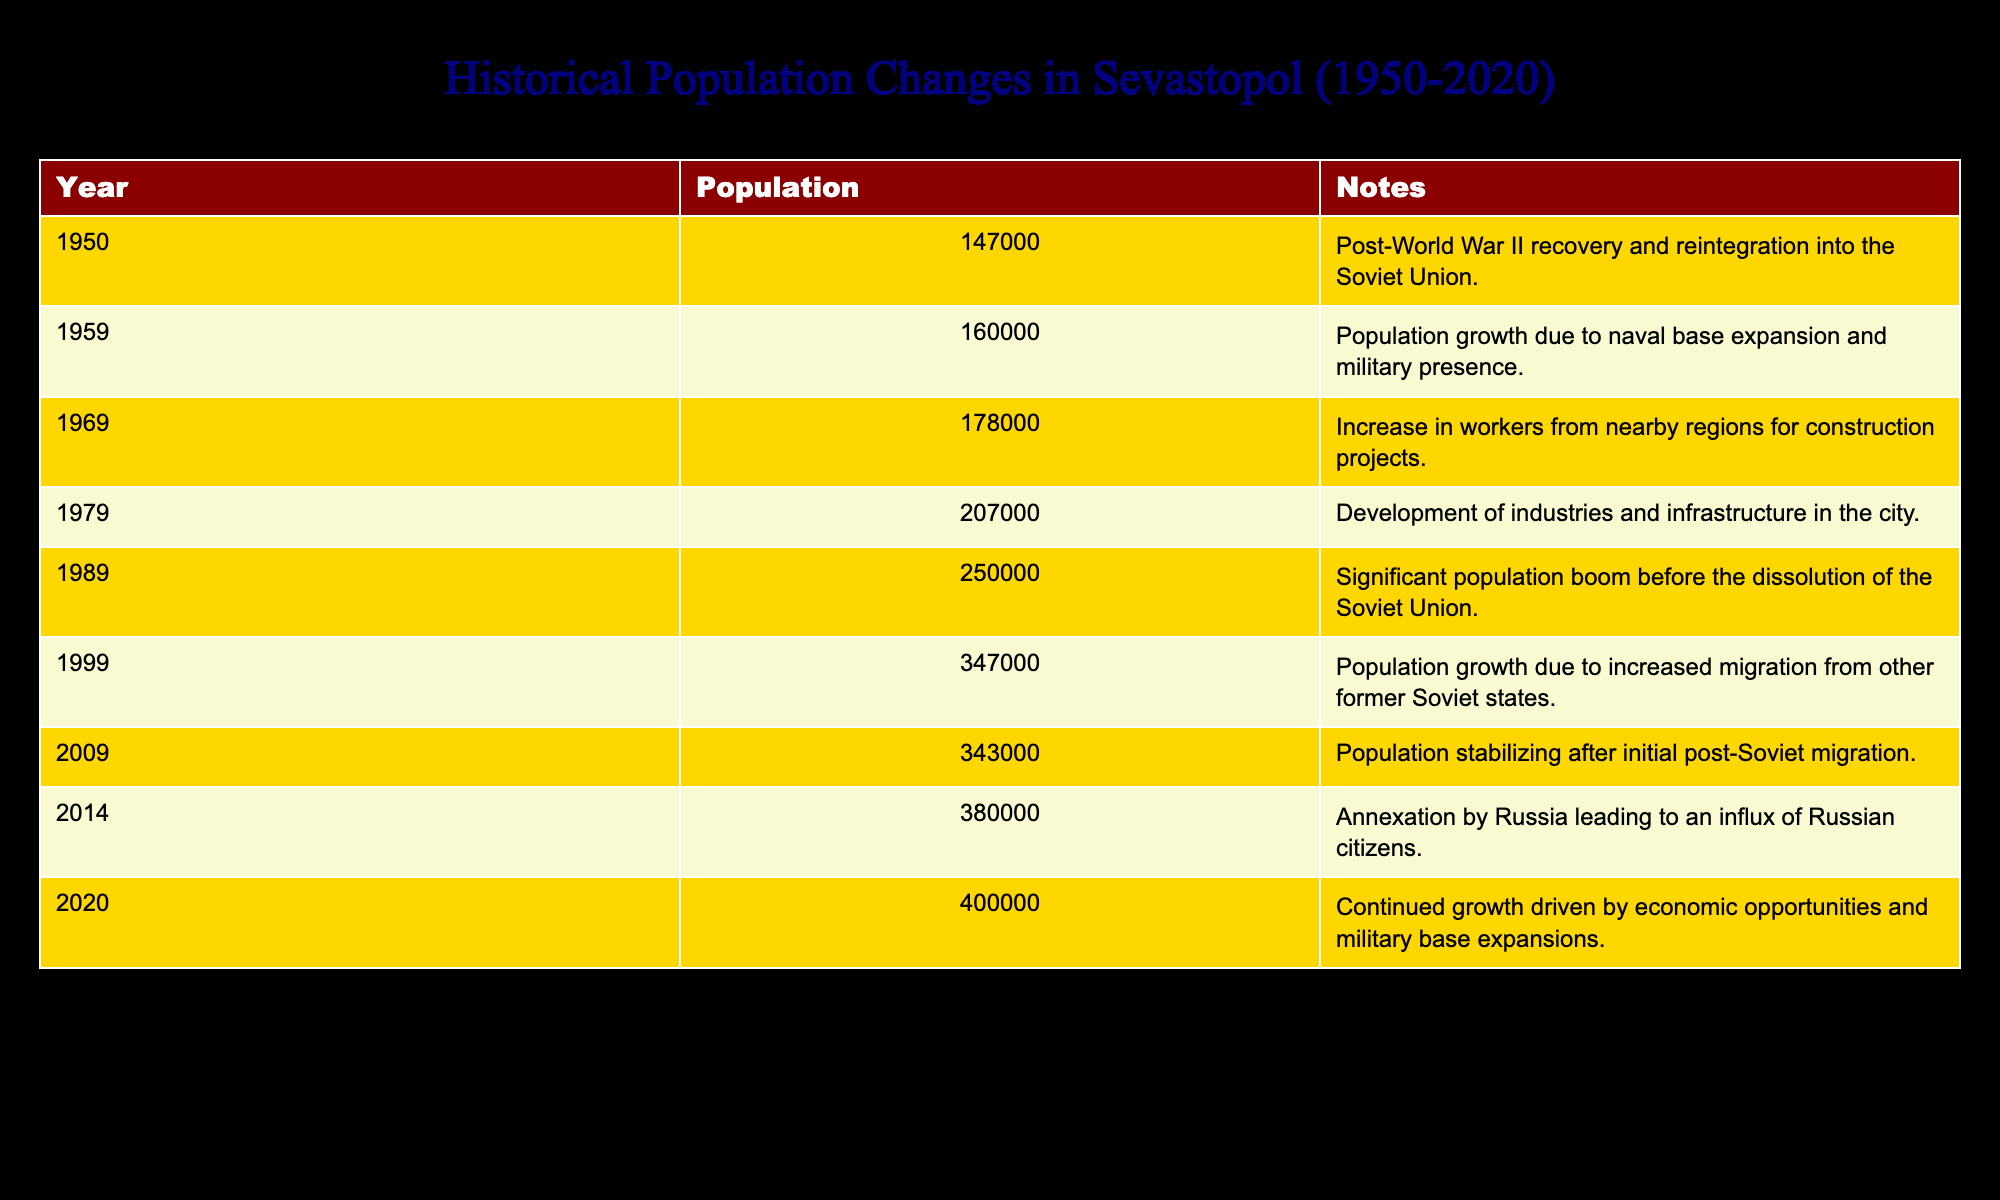What was the population of Sevastopol in 1989? According to the table, the row for the year 1989 lists a population of 250,000.
Answer: 250,000 Which year saw the highest population increase from the previous decade? To determine this, we compare the populations of each decade. The population increased from 1999 (347,000) to 2009 (343,000), which is a decrease, and from 2009 (343,000) to 2014 (380,000), which is an increase of 37,000. The highest increase is from 1989 (250,000) to 1999 (347,000), which is an increase of 97,000.
Answer: 1999 Was the population of Sevastopol above 300,000 in the year 2009? The table provides the population for 2009 as 343,000, which is above 300,000.
Answer: Yes What was the average population of Sevastopol between 1950 and 2020? To find the average, we sum the populations from each year and divide by the number of entries. The total population is 2,589,000 (147,000 + 160,000 + 178,000 + 207,000 + 250,000 + 347,000 + 343,000 + 380,000 + 400,000) and there are 9 years of data. The average is 2,589,000 divided by 9, which equals approximately 287,667.
Answer: Approximately 287,667 Which decade had the lowest population growth? By calculating the differences between corresponding years in adjacent decades, we find: 1950 to 1959 (13,000), 1959 to 1969 (18,000), 1969 to 1979 (29,000), 1979 to 1989 (43,000), 1989 to 1999 (97,000), 1999 to 2009 (-4,000), 2009 to 2014 (37,000), and 2014 to 2020 (20,000). The decade with the lowest growth is from 2009 to 2014 with an increase of just 37,000.
Answer: 2009 to 2014 Did the population of Sevastopol ever exceed 400,000 before 2020? The table shows that in the year 2020, the population reached 400,000, but the previous highest population listed is 380,000 in 2014. Therefore, it never exceeded 400,000 before then.
Answer: No 